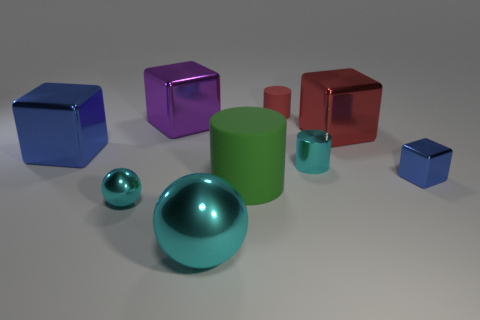There is a tiny red object on the right side of the sphere that is on the right side of the small cyan ball; what is its material?
Give a very brief answer. Rubber. There is a big purple thing behind the big cyan sphere; is it the same shape as the small thing that is on the left side of the large purple shiny thing?
Keep it short and to the point. No. There is a metal object that is both to the left of the purple block and behind the big green cylinder; how big is it?
Provide a short and direct response. Large. What number of other objects are the same color as the small cube?
Ensure brevity in your answer.  1. Are the small cylinder right of the tiny red matte cylinder and the large purple block made of the same material?
Provide a short and direct response. Yes. Is there any other thing that has the same size as the purple object?
Make the answer very short. Yes. Are there fewer large cyan shiny things that are behind the red rubber thing than cylinders that are on the left side of the big green rubber thing?
Your answer should be very brief. No. Are there any other things that are the same shape as the large purple shiny object?
Your answer should be very brief. Yes. There is another cube that is the same color as the small metallic cube; what is its material?
Your response must be concise. Metal. There is a matte thing that is behind the blue shiny cube that is left of the green matte cylinder; what number of large purple things are behind it?
Keep it short and to the point. 0. 